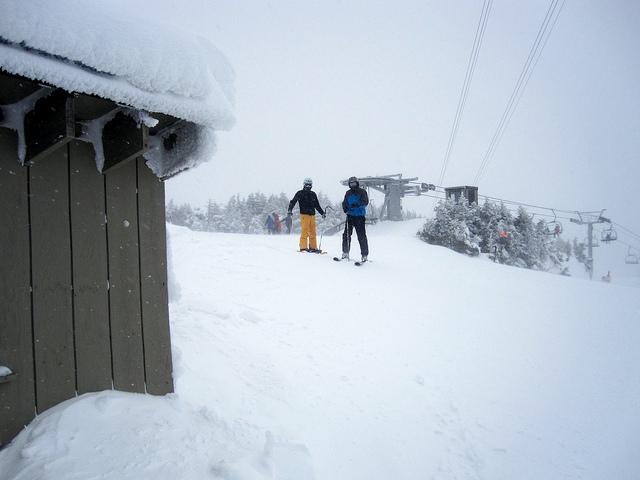What covers the ground?
Quick response, please. Snow. What color is the side of the building?
Give a very brief answer. Brown. Is it a sunny day?
Answer briefly. No. 